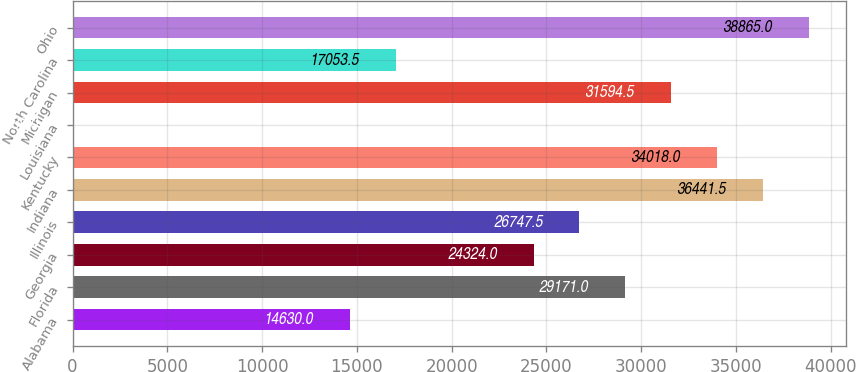Convert chart to OTSL. <chart><loc_0><loc_0><loc_500><loc_500><bar_chart><fcel>Alabama<fcel>Florida<fcel>Georgia<fcel>Illinois<fcel>Indiana<fcel>Kentucky<fcel>Louisiana<fcel>Michigan<fcel>North Carolina<fcel>Ohio<nl><fcel>14630<fcel>29171<fcel>24324<fcel>26747.5<fcel>36441.5<fcel>34018<fcel>89<fcel>31594.5<fcel>17053.5<fcel>38865<nl></chart> 